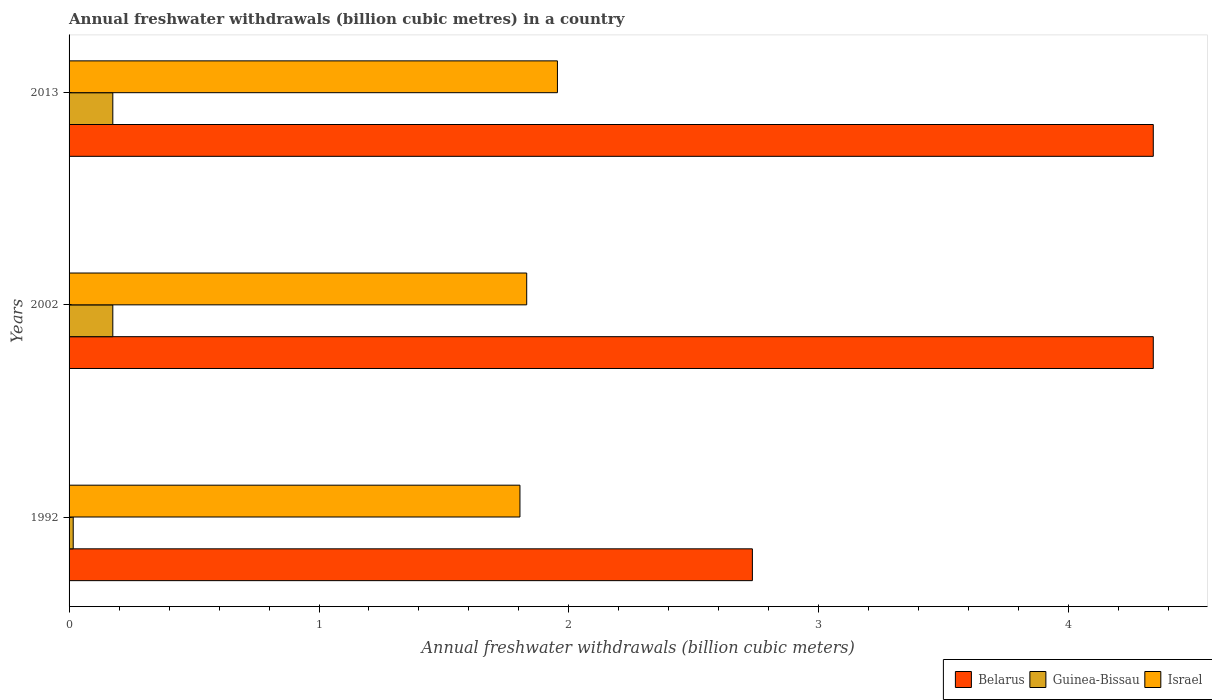Are the number of bars on each tick of the Y-axis equal?
Offer a very short reply. Yes. What is the label of the 2nd group of bars from the top?
Your response must be concise. 2002. What is the annual freshwater withdrawals in Guinea-Bissau in 2013?
Provide a short and direct response. 0.17. Across all years, what is the maximum annual freshwater withdrawals in Belarus?
Your answer should be compact. 4.34. Across all years, what is the minimum annual freshwater withdrawals in Belarus?
Give a very brief answer. 2.73. In which year was the annual freshwater withdrawals in Belarus maximum?
Your answer should be compact. 2002. What is the total annual freshwater withdrawals in Belarus in the graph?
Give a very brief answer. 11.41. What is the difference between the annual freshwater withdrawals in Guinea-Bissau in 1992 and that in 2013?
Offer a terse response. -0.16. What is the difference between the annual freshwater withdrawals in Belarus in 2013 and the annual freshwater withdrawals in Guinea-Bissau in 2002?
Provide a succinct answer. 4.16. What is the average annual freshwater withdrawals in Belarus per year?
Keep it short and to the point. 3.8. In the year 2002, what is the difference between the annual freshwater withdrawals in Belarus and annual freshwater withdrawals in Israel?
Provide a succinct answer. 2.51. What is the ratio of the annual freshwater withdrawals in Guinea-Bissau in 1992 to that in 2002?
Make the answer very short. 0.09. Is the annual freshwater withdrawals in Israel in 2002 less than that in 2013?
Keep it short and to the point. Yes. Is the difference between the annual freshwater withdrawals in Belarus in 2002 and 2013 greater than the difference between the annual freshwater withdrawals in Israel in 2002 and 2013?
Your answer should be very brief. Yes. What is the difference between the highest and the lowest annual freshwater withdrawals in Israel?
Provide a succinct answer. 0.15. Is the sum of the annual freshwater withdrawals in Israel in 2002 and 2013 greater than the maximum annual freshwater withdrawals in Belarus across all years?
Make the answer very short. No. What does the 2nd bar from the bottom in 1992 represents?
Offer a very short reply. Guinea-Bissau. Are all the bars in the graph horizontal?
Offer a terse response. Yes. Does the graph contain any zero values?
Provide a succinct answer. No. Does the graph contain grids?
Your answer should be compact. No. How are the legend labels stacked?
Your answer should be very brief. Horizontal. What is the title of the graph?
Make the answer very short. Annual freshwater withdrawals (billion cubic metres) in a country. What is the label or title of the X-axis?
Offer a terse response. Annual freshwater withdrawals (billion cubic meters). What is the label or title of the Y-axis?
Your answer should be very brief. Years. What is the Annual freshwater withdrawals (billion cubic meters) in Belarus in 1992?
Make the answer very short. 2.73. What is the Annual freshwater withdrawals (billion cubic meters) in Guinea-Bissau in 1992?
Provide a short and direct response. 0.02. What is the Annual freshwater withdrawals (billion cubic meters) in Israel in 1992?
Provide a short and direct response. 1.8. What is the Annual freshwater withdrawals (billion cubic meters) in Belarus in 2002?
Your response must be concise. 4.34. What is the Annual freshwater withdrawals (billion cubic meters) of Guinea-Bissau in 2002?
Ensure brevity in your answer.  0.17. What is the Annual freshwater withdrawals (billion cubic meters) of Israel in 2002?
Offer a very short reply. 1.83. What is the Annual freshwater withdrawals (billion cubic meters) of Belarus in 2013?
Provide a short and direct response. 4.34. What is the Annual freshwater withdrawals (billion cubic meters) in Guinea-Bissau in 2013?
Ensure brevity in your answer.  0.17. What is the Annual freshwater withdrawals (billion cubic meters) of Israel in 2013?
Your response must be concise. 1.95. Across all years, what is the maximum Annual freshwater withdrawals (billion cubic meters) in Belarus?
Offer a very short reply. 4.34. Across all years, what is the maximum Annual freshwater withdrawals (billion cubic meters) of Guinea-Bissau?
Offer a terse response. 0.17. Across all years, what is the maximum Annual freshwater withdrawals (billion cubic meters) of Israel?
Your response must be concise. 1.95. Across all years, what is the minimum Annual freshwater withdrawals (billion cubic meters) of Belarus?
Your response must be concise. 2.73. Across all years, what is the minimum Annual freshwater withdrawals (billion cubic meters) in Guinea-Bissau?
Your answer should be compact. 0.02. Across all years, what is the minimum Annual freshwater withdrawals (billion cubic meters) in Israel?
Offer a very short reply. 1.8. What is the total Annual freshwater withdrawals (billion cubic meters) of Belarus in the graph?
Provide a succinct answer. 11.41. What is the total Annual freshwater withdrawals (billion cubic meters) of Guinea-Bissau in the graph?
Keep it short and to the point. 0.37. What is the total Annual freshwater withdrawals (billion cubic meters) of Israel in the graph?
Give a very brief answer. 5.59. What is the difference between the Annual freshwater withdrawals (billion cubic meters) of Belarus in 1992 and that in 2002?
Offer a very short reply. -1.6. What is the difference between the Annual freshwater withdrawals (billion cubic meters) in Guinea-Bissau in 1992 and that in 2002?
Make the answer very short. -0.16. What is the difference between the Annual freshwater withdrawals (billion cubic meters) in Israel in 1992 and that in 2002?
Your answer should be compact. -0.03. What is the difference between the Annual freshwater withdrawals (billion cubic meters) in Belarus in 1992 and that in 2013?
Offer a very short reply. -1.6. What is the difference between the Annual freshwater withdrawals (billion cubic meters) in Guinea-Bissau in 1992 and that in 2013?
Make the answer very short. -0.16. What is the difference between the Annual freshwater withdrawals (billion cubic meters) of Belarus in 2002 and that in 2013?
Give a very brief answer. 0. What is the difference between the Annual freshwater withdrawals (billion cubic meters) of Guinea-Bissau in 2002 and that in 2013?
Keep it short and to the point. 0. What is the difference between the Annual freshwater withdrawals (billion cubic meters) of Israel in 2002 and that in 2013?
Keep it short and to the point. -0.12. What is the difference between the Annual freshwater withdrawals (billion cubic meters) of Belarus in 1992 and the Annual freshwater withdrawals (billion cubic meters) of Guinea-Bissau in 2002?
Ensure brevity in your answer.  2.56. What is the difference between the Annual freshwater withdrawals (billion cubic meters) of Belarus in 1992 and the Annual freshwater withdrawals (billion cubic meters) of Israel in 2002?
Keep it short and to the point. 0.9. What is the difference between the Annual freshwater withdrawals (billion cubic meters) in Guinea-Bissau in 1992 and the Annual freshwater withdrawals (billion cubic meters) in Israel in 2002?
Your answer should be very brief. -1.81. What is the difference between the Annual freshwater withdrawals (billion cubic meters) in Belarus in 1992 and the Annual freshwater withdrawals (billion cubic meters) in Guinea-Bissau in 2013?
Provide a succinct answer. 2.56. What is the difference between the Annual freshwater withdrawals (billion cubic meters) of Belarus in 1992 and the Annual freshwater withdrawals (billion cubic meters) of Israel in 2013?
Offer a very short reply. 0.78. What is the difference between the Annual freshwater withdrawals (billion cubic meters) of Guinea-Bissau in 1992 and the Annual freshwater withdrawals (billion cubic meters) of Israel in 2013?
Your answer should be compact. -1.94. What is the difference between the Annual freshwater withdrawals (billion cubic meters) in Belarus in 2002 and the Annual freshwater withdrawals (billion cubic meters) in Guinea-Bissau in 2013?
Your response must be concise. 4.16. What is the difference between the Annual freshwater withdrawals (billion cubic meters) in Belarus in 2002 and the Annual freshwater withdrawals (billion cubic meters) in Israel in 2013?
Provide a short and direct response. 2.38. What is the difference between the Annual freshwater withdrawals (billion cubic meters) of Guinea-Bissau in 2002 and the Annual freshwater withdrawals (billion cubic meters) of Israel in 2013?
Your answer should be compact. -1.78. What is the average Annual freshwater withdrawals (billion cubic meters) in Belarus per year?
Keep it short and to the point. 3.8. What is the average Annual freshwater withdrawals (billion cubic meters) of Guinea-Bissau per year?
Keep it short and to the point. 0.12. What is the average Annual freshwater withdrawals (billion cubic meters) of Israel per year?
Make the answer very short. 1.86. In the year 1992, what is the difference between the Annual freshwater withdrawals (billion cubic meters) in Belarus and Annual freshwater withdrawals (billion cubic meters) in Guinea-Bissau?
Offer a terse response. 2.72. In the year 1992, what is the difference between the Annual freshwater withdrawals (billion cubic meters) of Guinea-Bissau and Annual freshwater withdrawals (billion cubic meters) of Israel?
Ensure brevity in your answer.  -1.79. In the year 2002, what is the difference between the Annual freshwater withdrawals (billion cubic meters) in Belarus and Annual freshwater withdrawals (billion cubic meters) in Guinea-Bissau?
Offer a very short reply. 4.16. In the year 2002, what is the difference between the Annual freshwater withdrawals (billion cubic meters) of Belarus and Annual freshwater withdrawals (billion cubic meters) of Israel?
Give a very brief answer. 2.51. In the year 2002, what is the difference between the Annual freshwater withdrawals (billion cubic meters) of Guinea-Bissau and Annual freshwater withdrawals (billion cubic meters) of Israel?
Your answer should be compact. -1.66. In the year 2013, what is the difference between the Annual freshwater withdrawals (billion cubic meters) in Belarus and Annual freshwater withdrawals (billion cubic meters) in Guinea-Bissau?
Make the answer very short. 4.16. In the year 2013, what is the difference between the Annual freshwater withdrawals (billion cubic meters) of Belarus and Annual freshwater withdrawals (billion cubic meters) of Israel?
Make the answer very short. 2.38. In the year 2013, what is the difference between the Annual freshwater withdrawals (billion cubic meters) in Guinea-Bissau and Annual freshwater withdrawals (billion cubic meters) in Israel?
Your answer should be compact. -1.78. What is the ratio of the Annual freshwater withdrawals (billion cubic meters) of Belarus in 1992 to that in 2002?
Offer a very short reply. 0.63. What is the ratio of the Annual freshwater withdrawals (billion cubic meters) in Guinea-Bissau in 1992 to that in 2002?
Your response must be concise. 0.09. What is the ratio of the Annual freshwater withdrawals (billion cubic meters) of Belarus in 1992 to that in 2013?
Ensure brevity in your answer.  0.63. What is the ratio of the Annual freshwater withdrawals (billion cubic meters) of Guinea-Bissau in 1992 to that in 2013?
Your answer should be compact. 0.09. What is the ratio of the Annual freshwater withdrawals (billion cubic meters) of Israel in 1992 to that in 2013?
Offer a terse response. 0.92. What is the ratio of the Annual freshwater withdrawals (billion cubic meters) of Belarus in 2002 to that in 2013?
Keep it short and to the point. 1. What is the ratio of the Annual freshwater withdrawals (billion cubic meters) in Guinea-Bissau in 2002 to that in 2013?
Your answer should be compact. 1. What is the ratio of the Annual freshwater withdrawals (billion cubic meters) of Israel in 2002 to that in 2013?
Offer a terse response. 0.94. What is the difference between the highest and the second highest Annual freshwater withdrawals (billion cubic meters) of Israel?
Your answer should be very brief. 0.12. What is the difference between the highest and the lowest Annual freshwater withdrawals (billion cubic meters) of Belarus?
Ensure brevity in your answer.  1.6. What is the difference between the highest and the lowest Annual freshwater withdrawals (billion cubic meters) in Guinea-Bissau?
Ensure brevity in your answer.  0.16. What is the difference between the highest and the lowest Annual freshwater withdrawals (billion cubic meters) of Israel?
Ensure brevity in your answer.  0.15. 